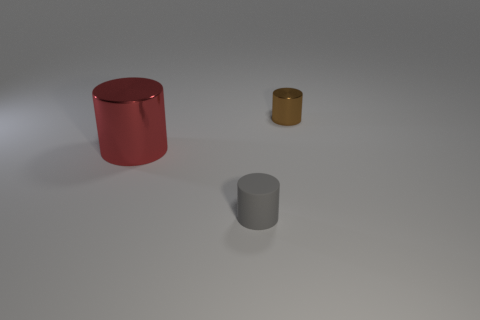There is another tiny object that is the same shape as the gray rubber object; what is it made of?
Your response must be concise. Metal. How many objects are metal cylinders behind the big red thing or cylinders that are in front of the big shiny cylinder?
Keep it short and to the point. 2. There is a big cylinder; does it have the same color as the tiny thing in front of the tiny brown cylinder?
Keep it short and to the point. No. How many big brown metallic cylinders are there?
Your response must be concise. 0. What number of things are metal cylinders that are on the right side of the red metallic object or large green matte blocks?
Make the answer very short. 1. There is a shiny thing that is on the left side of the brown metal object; is it the same color as the matte object?
Your answer should be very brief. No. How many other objects are there of the same color as the large metallic object?
Offer a very short reply. 0. What number of tiny things are either gray cylinders or red shiny cylinders?
Give a very brief answer. 1. Are there more large things than tiny purple shiny balls?
Give a very brief answer. Yes. Do the tiny gray cylinder and the big thing have the same material?
Give a very brief answer. No. 